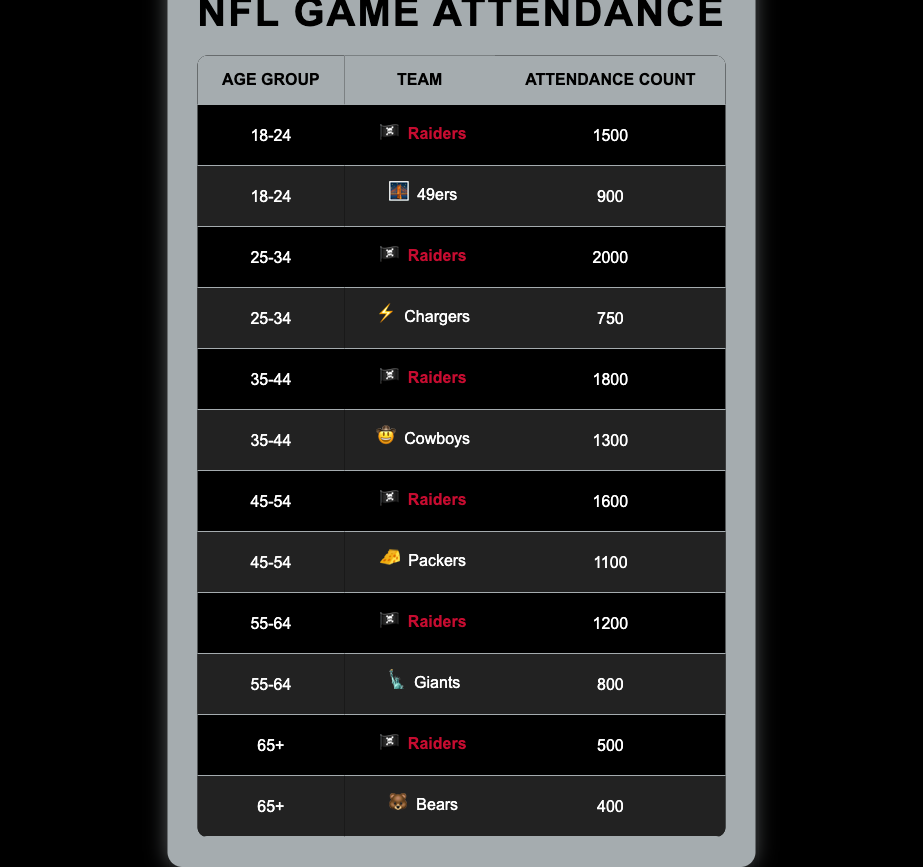What age group has the highest attendance for the Raiders? The attendance for the Raiders in each age group is: 18-24: 1500, 25-34: 2000, 35-44: 1800, 45-54: 1600, 55-64: 1200, and 65+: 500. The highest value among these is 2000, for the age group 25-34.
Answer: 25-34 What is the total attendance for the Raiders across all age groups? The individual attendances for the Raiders are: 1500 (18-24) + 2000 (25-34) + 1800 (35-44) + 1600 (45-54) + 1200 (55-64) + 500 (65+). Summing these gives: 1500 + 2000 + 1800 + 1600 + 1200 + 500 = 9600.
Answer: 9600 How many more fans attended Raiders games in the 25-34 age group compared to the 45-54 age group? The attendance in the 25-34 age group is 2000, while in the 45-54 age group it is 1600. To find the difference, subtract the latter from the former: 2000 - 1600 = 400.
Answer: 400 True or False: More people attended Cowboys games than Raiders games in the 35-44 age group. The attendance for the Raiders in the 35-44 age group is 1800, while the Cowboys had 1300 attendees. Since 1800 is greater than 1300, the statement is false.
Answer: False What is the average attendance for the Raiders across all age groups? The attendances are 1500, 2000, 1800, 1600, 1200, and 500. To find the average, first sum these values: 1500 + 2000 + 1800 + 1600 + 1200 + 500 = 9600. There are 6 data points, so the average is 9600 / 6 = 1600.
Answer: 1600 